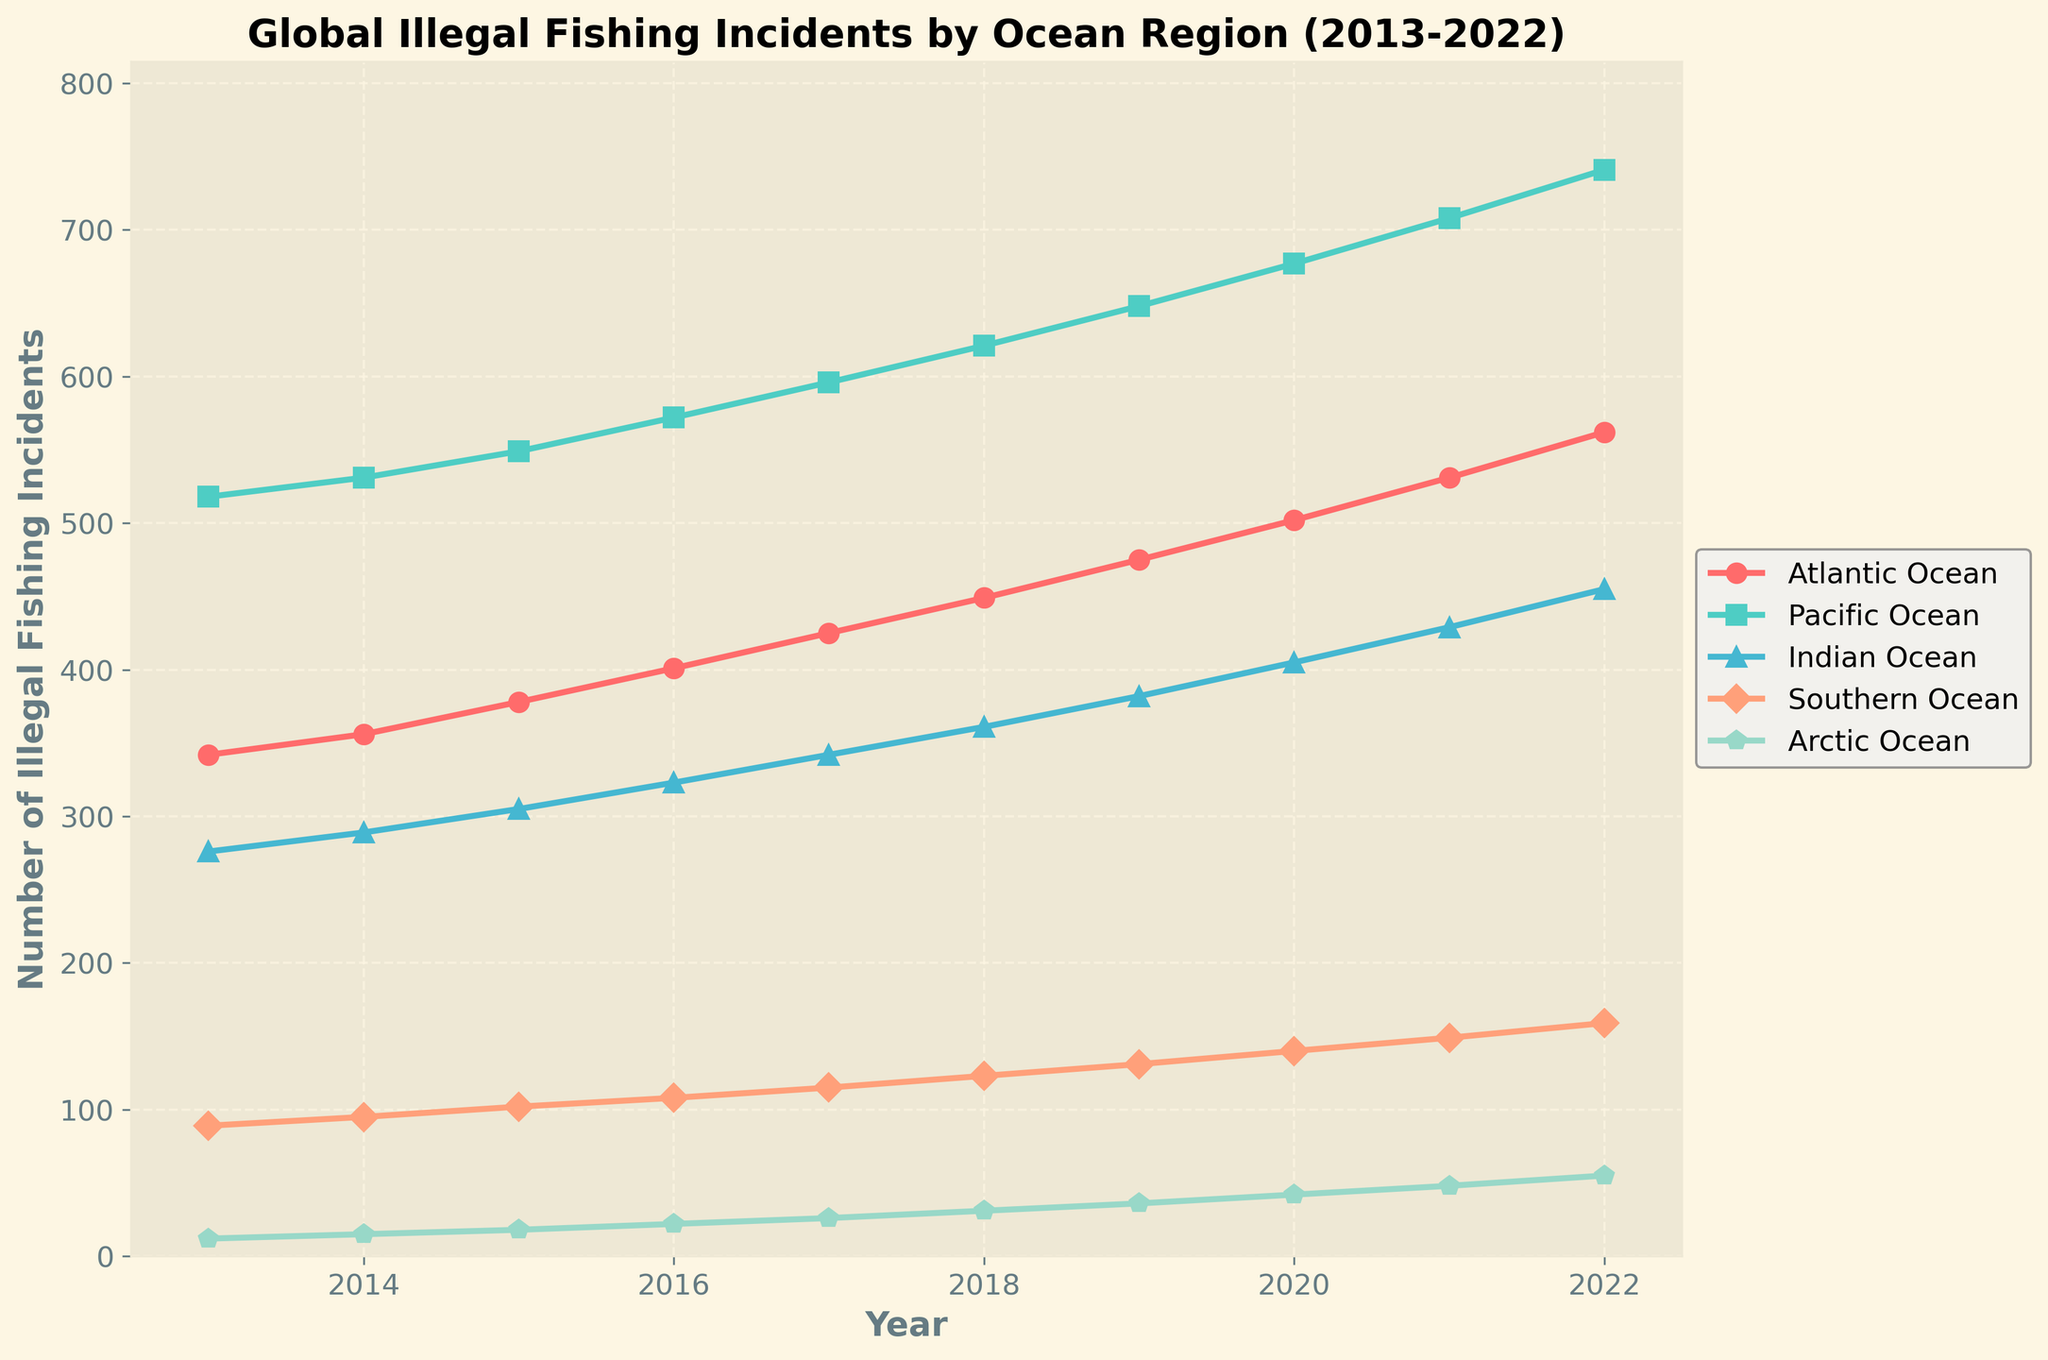Which ocean region had the highest number of illegal fishing incidents in 2022? According to the chart, in 2022, the Pacific Ocean has the highest number of illegal fishing incidents compared to other regions.
Answer: Pacific Ocean What is the total number of illegal fishing incidents reported in the Atlantic Ocean over the entire period from 2013 to 2022? To find the total, sum the data points for the Atlantic Ocean across all years: 342 + 356 + 378 + 401 + 425 + 449 + 475 + 502 + 531 + 562 = 4421
Answer: 4421 How many more illegal fishing incidents were there in the Pacific Ocean in 2022 compared to the Atlantic Ocean? From the chart, the number of incidents in 2022 is 741 for the Pacific Ocean and 562 for the Atlantic Ocean, so the difference is 741 - 562 = 179
Answer: 179 Which ocean region showed the largest increase in illegal fishing incidents from 2013 to 2022? By observing the chart, the increase for each ocean from 2013 to 2022 can be calculated. The Pacific Ocean went from 518 to 741, an increase of 223, which is the largest among the regions.
Answer: Pacific Ocean Was there any year where the number of illegal fishing incidents in the Southern Ocean was more than 60% of those in the Pacific Ocean in that same year? No. In each year, 60% of the Pacific Ocean incidents can be calculated (e.g., in 2013: 60% of 518 = 310.8) and compared to the Southern Ocean incidents. The Southern Ocean never surpasses this threshold.
Answer: No What was the average annual growth rate of illegal fishing incidents in the Arctic Ocean from 2013 to 2022? The growth rate can be estimated by calculating the overall increase (55 - 12 = 43) and dividing by the number of years (2022 - 2013 = 9): 43/9 ≈ 4.78 incidents per year.
Answer: 4.78 In which year did the Atlantic Ocean see an increase in illegal fishing incidents that matched the same year's increase in the Pacific Ocean? By comparing annual increases year-on-year, for example, from 2013 to 2014, Atlantic Ocean increased by (356 - 342 = 14) and Pacific Ocean increased by (531 - 518 = 13). No exact match was found across all years.
Answer: No year Which ocean shows the smallest growth in illegal fishing incidents over the decade? The smallest growth from 2013 to 2022 is in the Arctic Ocean with an increase of (55 - 12 = 43) incidents.
Answer: Arctic Ocean If the trends continue, which ocean is most likely to reach 800 incidents first? Observing the trends, the Pacific Ocean has the steepest and fastest growth rate. Extrapolating, it's likely to hit 800 incidents before the other oceans.
Answer: Pacific Ocean 